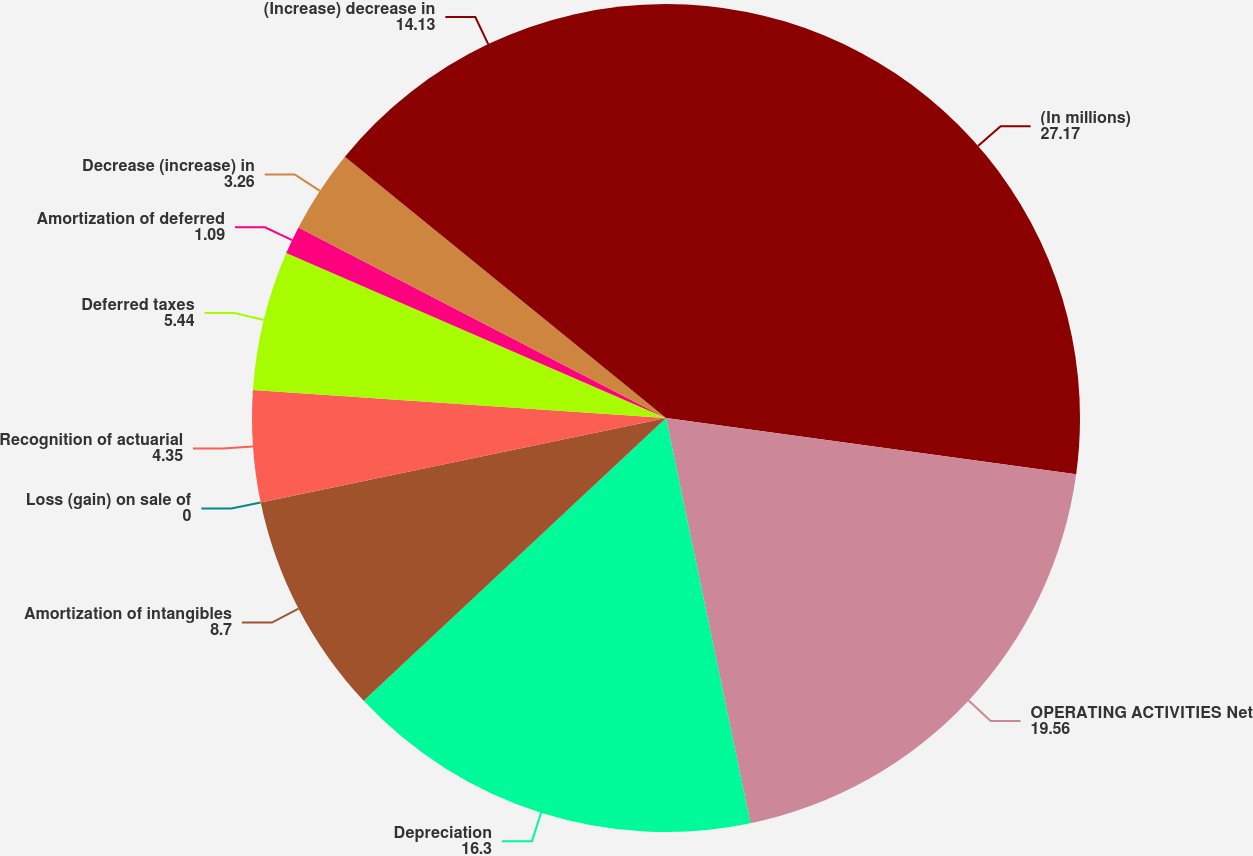<chart> <loc_0><loc_0><loc_500><loc_500><pie_chart><fcel>(In millions)<fcel>OPERATING ACTIVITIES Net<fcel>Depreciation<fcel>Amortization of intangibles<fcel>Loss (gain) on sale of<fcel>Recognition of actuarial<fcel>Deferred taxes<fcel>Amortization of deferred<fcel>Decrease (increase) in<fcel>(Increase) decrease in<nl><fcel>27.17%<fcel>19.56%<fcel>16.3%<fcel>8.7%<fcel>0.0%<fcel>4.35%<fcel>5.44%<fcel>1.09%<fcel>3.26%<fcel>14.13%<nl></chart> 